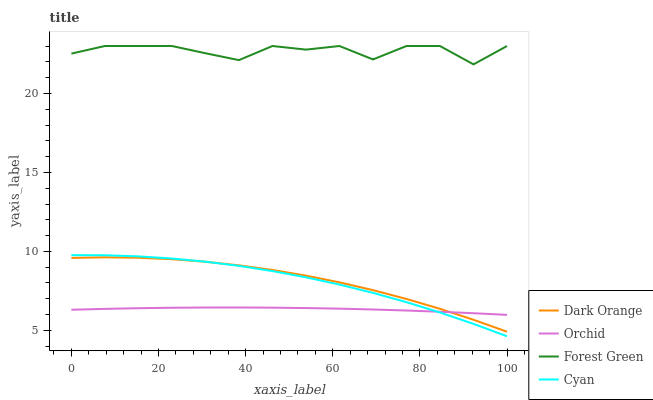Does Orchid have the minimum area under the curve?
Answer yes or no. Yes. Does Forest Green have the maximum area under the curve?
Answer yes or no. Yes. Does Cyan have the minimum area under the curve?
Answer yes or no. No. Does Cyan have the maximum area under the curve?
Answer yes or no. No. Is Orchid the smoothest?
Answer yes or no. Yes. Is Forest Green the roughest?
Answer yes or no. Yes. Is Cyan the smoothest?
Answer yes or no. No. Is Cyan the roughest?
Answer yes or no. No. Does Cyan have the lowest value?
Answer yes or no. Yes. Does Forest Green have the lowest value?
Answer yes or no. No. Does Forest Green have the highest value?
Answer yes or no. Yes. Does Cyan have the highest value?
Answer yes or no. No. Is Dark Orange less than Forest Green?
Answer yes or no. Yes. Is Forest Green greater than Cyan?
Answer yes or no. Yes. Does Dark Orange intersect Cyan?
Answer yes or no. Yes. Is Dark Orange less than Cyan?
Answer yes or no. No. Is Dark Orange greater than Cyan?
Answer yes or no. No. Does Dark Orange intersect Forest Green?
Answer yes or no. No. 